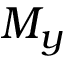Convert formula to latex. <formula><loc_0><loc_0><loc_500><loc_500>M _ { y }</formula> 